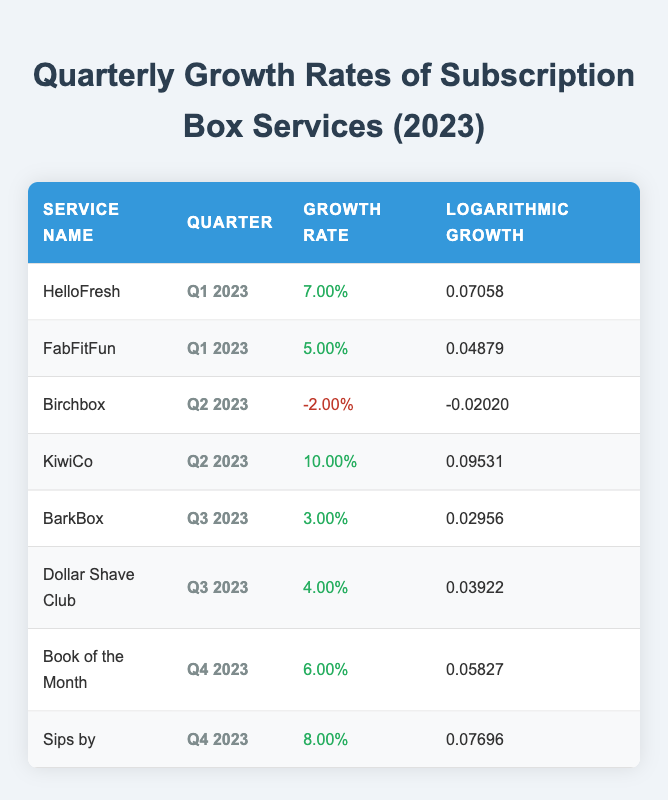What is the growth rate for KiwiCo in Q2 2023? The table lists the growth rate for KiwiCo in Q2 2023 as 10.00%.
Answer: 10.00% Which subscription box service had the lowest growth rate in Q2 2023? By comparing the growth rates in Q2 2023, Birchbox has a growth rate of -2.00%, which is lower than KiwiCo's 10.00%.
Answer: Birchbox What is the average growth rate for all services in Q3 2023? The services in Q3 2023 are BarkBox (3.00%) and Dollar Shave Club (4.00%). Adding these gives 7.00%. Dividing by the number of services (2) results in an average of 3.50%.
Answer: 3.50% Did HelloFresh have a higher growth rate than Sips by in Q4 2023? HelloFresh's growth rate is not available for Q4 2023, but comparing Sips by's Q4 growth rate of 8.00% with HelloFresh's Q1 growth rate of 7.00% shows that Sips by has a higher growth rate for its available quarter.
Answer: Yes What was the total growth rate for all services over Q1, Q2, Q3, and Q4 of 2023? To find the total growth rate, all growth rates across the four quarters need to be summed: 7.00% + 5.00% - 2.00% + 10.00% + 3.00% + 4.00% + 6.00% + 8.00% results in a total of 41.00%.
Answer: 41.00% 